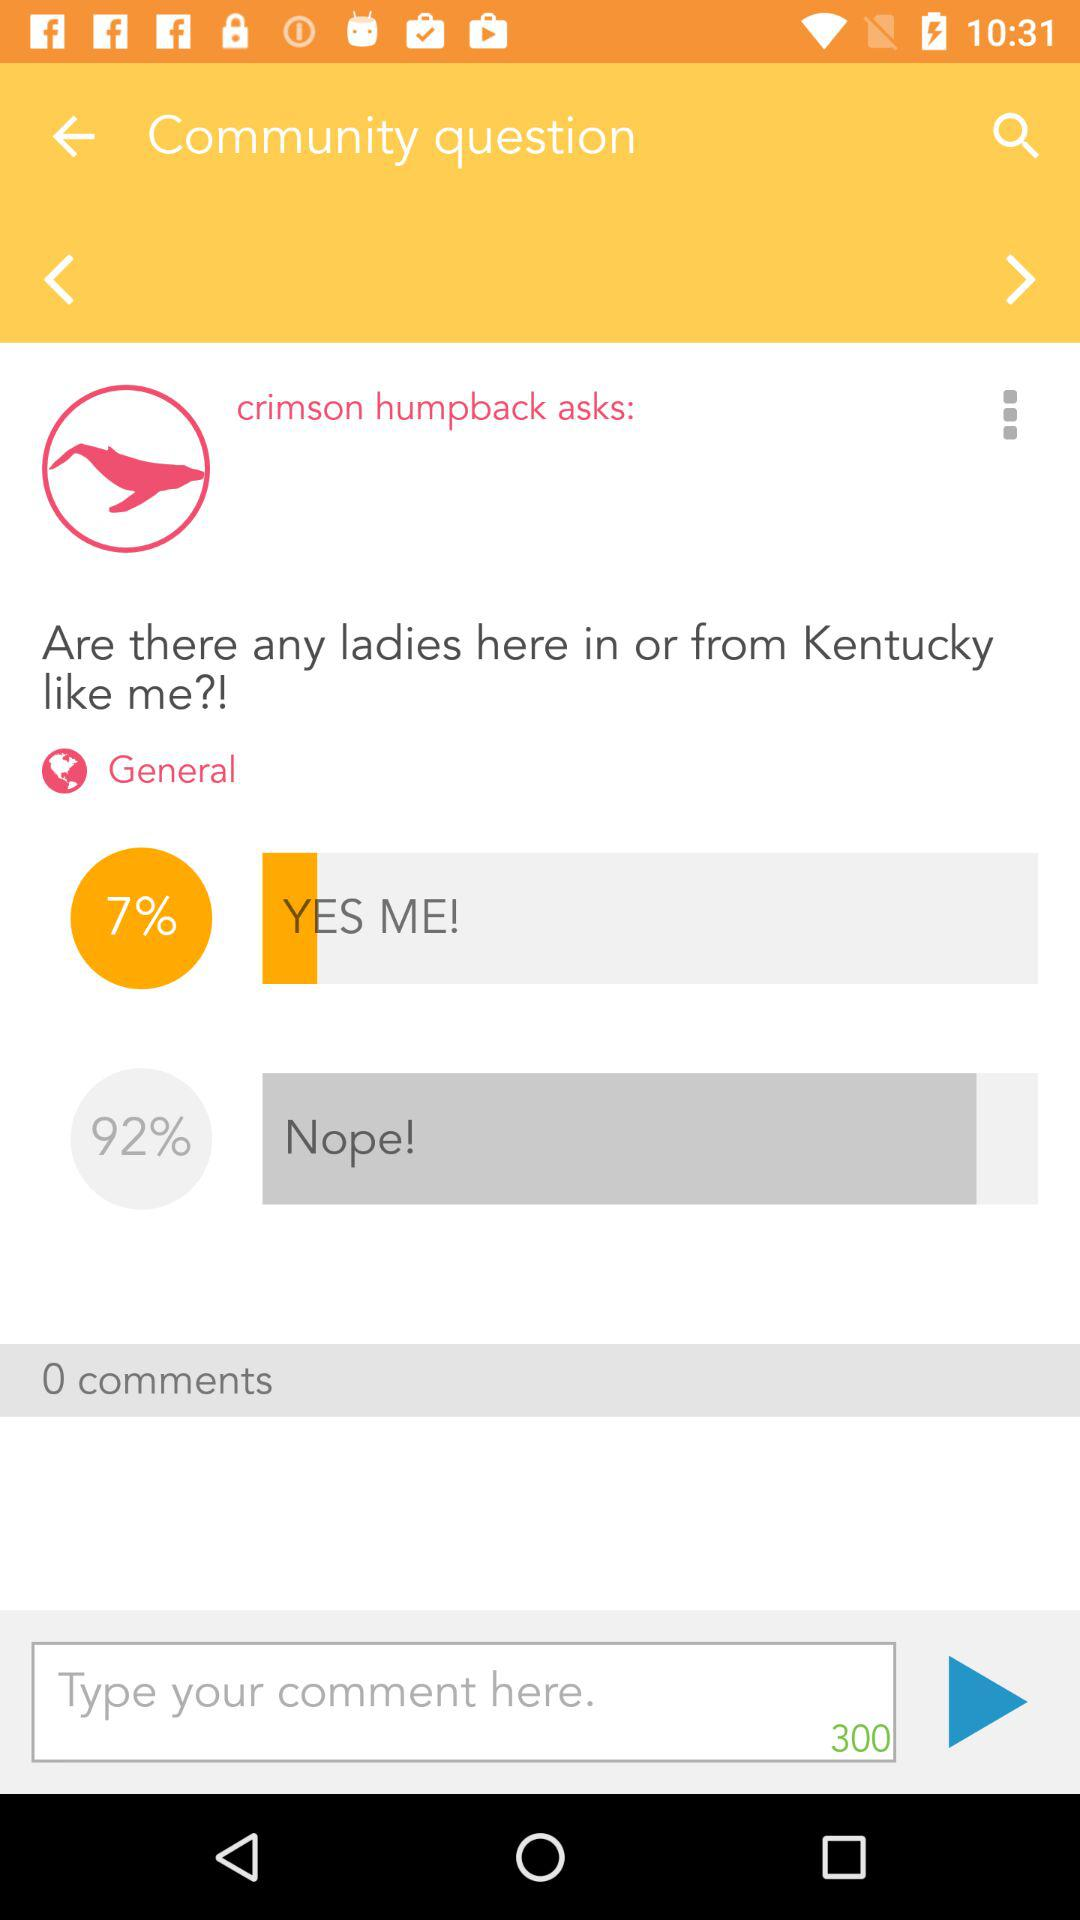What is the maximum word limit?
When the provided information is insufficient, respond with <no answer>. <no answer> 